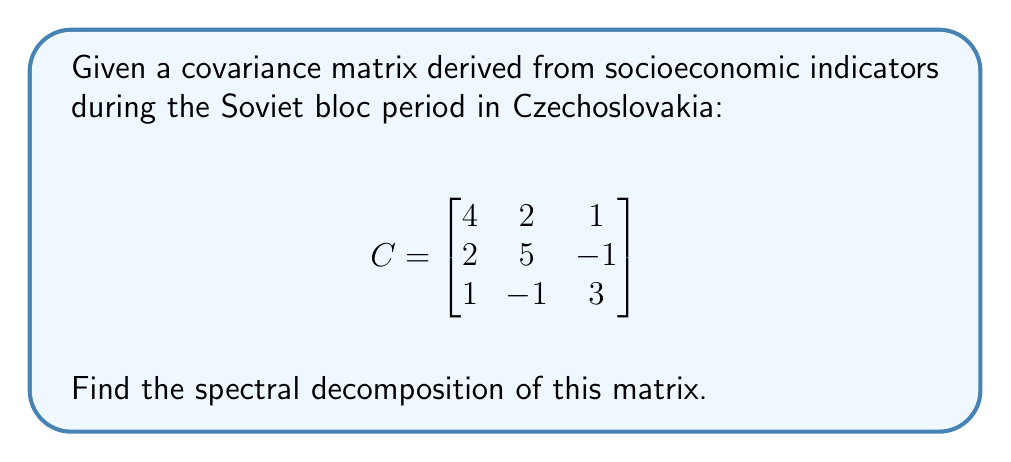Show me your answer to this math problem. 1) To find the spectral decomposition, we need to find the eigenvalues and eigenvectors of the matrix.

2) First, let's find the eigenvalues by solving the characteristic equation:
   $$det(C - \lambda I) = 0$$
   
   $$\begin{vmatrix}
   4-\lambda & 2 & 1 \\
   2 & 5-\lambda & -1 \\
   1 & -1 & 3-\lambda
   \end{vmatrix} = 0$$

3) Expanding this determinant:
   $$(\lambda-1)(\lambda-3)(\lambda-8) = 0$$

4) The eigenvalues are $\lambda_1 = 1$, $\lambda_2 = 3$, and $\lambda_3 = 8$.

5) Now, let's find the eigenvectors for each eigenvalue:

   For $\lambda_1 = 1$:
   $$(C - I)\vec{v}_1 = \vec{0}$$
   Solving this, we get $\vec{v}_1 = (1, -1, 1)^T$

   For $\lambda_2 = 3$:
   $$(C - 3I)\vec{v}_2 = \vec{0}$$
   Solving this, we get $\vec{v}_2 = (-1, 0, 1)^T$

   For $\lambda_3 = 8$:
   $$(C - 8I)\vec{v}_3 = \vec{0}$$
   Solving this, we get $\vec{v}_3 = (1, 2, 1)^T$

6) Normalize these eigenvectors:
   $$\vec{u}_1 = \frac{1}{\sqrt{3}}(1, -1, 1)^T$$
   $$\vec{u}_2 = \frac{1}{\sqrt{2}}(-1, 0, 1)^T$$
   $$\vec{u}_3 = \frac{1}{\sqrt{6}}(1, 2, 1)^T$$

7) The spectral decomposition is:
   $$C = \lambda_1 \vec{u}_1\vec{u}_1^T + \lambda_2 \vec{u}_2\vec{u}_2^T + \lambda_3 \vec{u}_3\vec{u}_3^T$$

8) In matrix form:
   $$C = UDU^T$$
   where $U = [\vec{u}_1 \vec{u}_2 \vec{u}_3]$ and $D = diag(1, 3, 8)$
Answer: $C = UDU^T$, where $U = [\frac{1}{\sqrt{3}}(1, -1, 1)^T, \frac{1}{\sqrt{2}}(-1, 0, 1)^T, \frac{1}{\sqrt{6}}(1, 2, 1)^T]$ and $D = diag(1, 3, 8)$ 